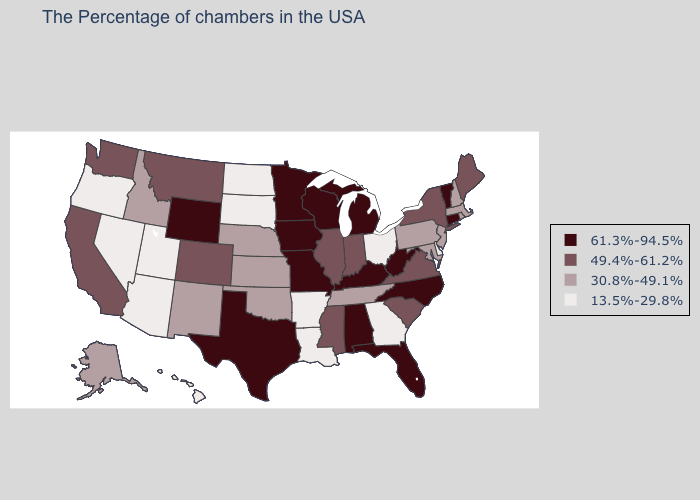Name the states that have a value in the range 61.3%-94.5%?
Short answer required. Vermont, Connecticut, North Carolina, West Virginia, Florida, Michigan, Kentucky, Alabama, Wisconsin, Missouri, Minnesota, Iowa, Texas, Wyoming. Which states have the lowest value in the USA?
Quick response, please. Delaware, Ohio, Georgia, Louisiana, Arkansas, South Dakota, North Dakota, Utah, Arizona, Nevada, Oregon, Hawaii. Name the states that have a value in the range 30.8%-49.1%?
Be succinct. Massachusetts, Rhode Island, New Hampshire, New Jersey, Maryland, Pennsylvania, Tennessee, Kansas, Nebraska, Oklahoma, New Mexico, Idaho, Alaska. Does Alaska have the lowest value in the USA?
Short answer required. No. What is the lowest value in the USA?
Give a very brief answer. 13.5%-29.8%. Name the states that have a value in the range 13.5%-29.8%?
Be succinct. Delaware, Ohio, Georgia, Louisiana, Arkansas, South Dakota, North Dakota, Utah, Arizona, Nevada, Oregon, Hawaii. Name the states that have a value in the range 30.8%-49.1%?
Keep it brief. Massachusetts, Rhode Island, New Hampshire, New Jersey, Maryland, Pennsylvania, Tennessee, Kansas, Nebraska, Oklahoma, New Mexico, Idaho, Alaska. Name the states that have a value in the range 61.3%-94.5%?
Short answer required. Vermont, Connecticut, North Carolina, West Virginia, Florida, Michigan, Kentucky, Alabama, Wisconsin, Missouri, Minnesota, Iowa, Texas, Wyoming. How many symbols are there in the legend?
Keep it brief. 4. Is the legend a continuous bar?
Keep it brief. No. Does the first symbol in the legend represent the smallest category?
Keep it brief. No. Which states have the highest value in the USA?
Give a very brief answer. Vermont, Connecticut, North Carolina, West Virginia, Florida, Michigan, Kentucky, Alabama, Wisconsin, Missouri, Minnesota, Iowa, Texas, Wyoming. Name the states that have a value in the range 13.5%-29.8%?
Keep it brief. Delaware, Ohio, Georgia, Louisiana, Arkansas, South Dakota, North Dakota, Utah, Arizona, Nevada, Oregon, Hawaii. Does the map have missing data?
Short answer required. No. What is the value of Louisiana?
Be succinct. 13.5%-29.8%. 